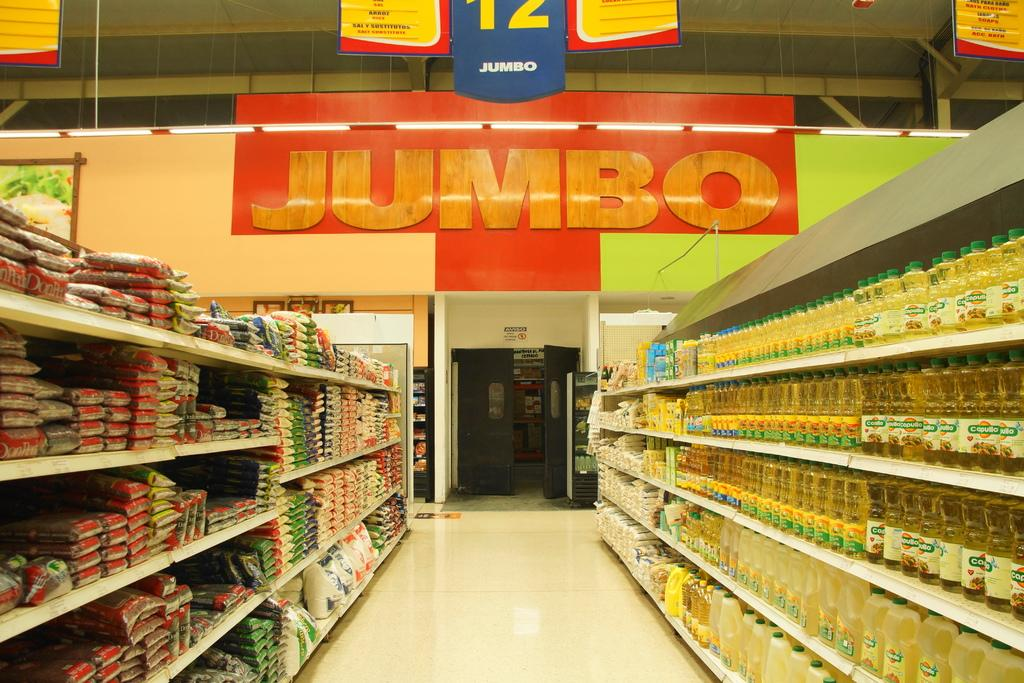<image>
Render a clear and concise summary of the photo. Looking up aisle 12 in a store called Jumbo. 